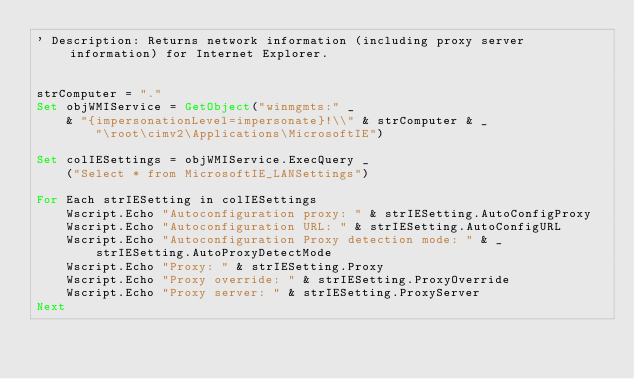<code> <loc_0><loc_0><loc_500><loc_500><_VisualBasic_>' Description: Returns network information (including proxy server information) for Internet Explorer.


strComputer = "."
Set objWMIService = GetObject("winmgmts:" _
    & "{impersonationLevel=impersonate}!\\" & strComputer & _
        "\root\cimv2\Applications\MicrosoftIE")

Set colIESettings = objWMIService.ExecQuery _
    ("Select * from MicrosoftIE_LANSettings")

For Each strIESetting in colIESettings
    Wscript.Echo "Autoconfiguration proxy: " & strIESetting.AutoConfigProxy
    Wscript.Echo "Autoconfiguration URL: " & strIESetting.AutoConfigURL
    Wscript.Echo "Autoconfiguration Proxy detection mode: " & _
        strIESetting.AutoProxyDetectMode
    Wscript.Echo "Proxy: " & strIESetting.Proxy
    Wscript.Echo "Proxy override: " & strIESetting.ProxyOverride
    Wscript.Echo "Proxy server: " & strIESetting.ProxyServer
Next

</code> 